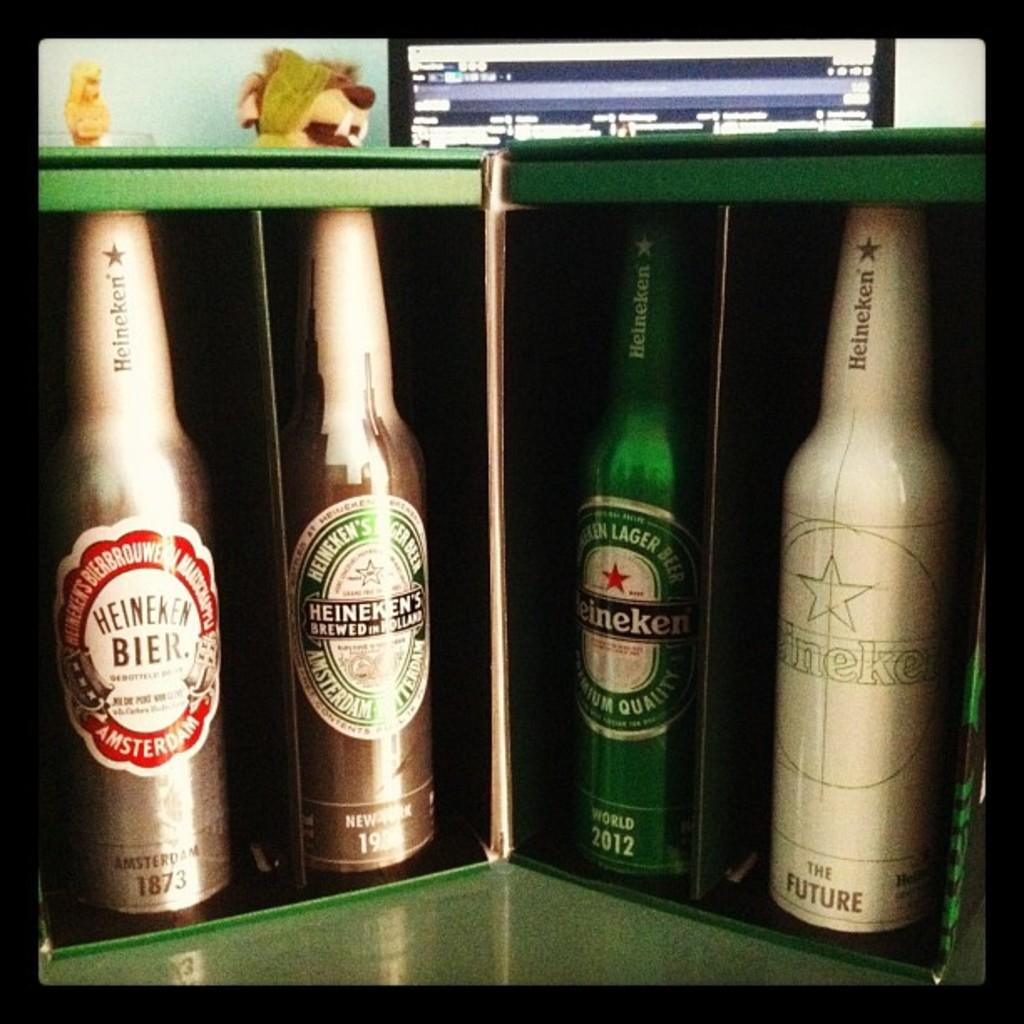<image>
Describe the image concisely. th word bier is on a bottle on the green surface 